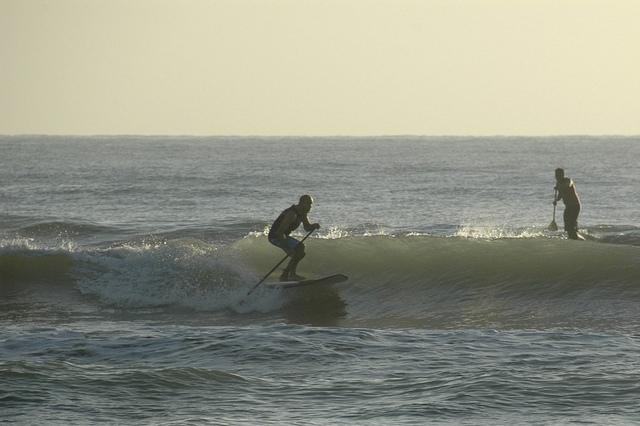What type of equipment are the people holding?

Choices:
A) oars
B) water propellers
C) rowing sticks
D) surf poles oars 